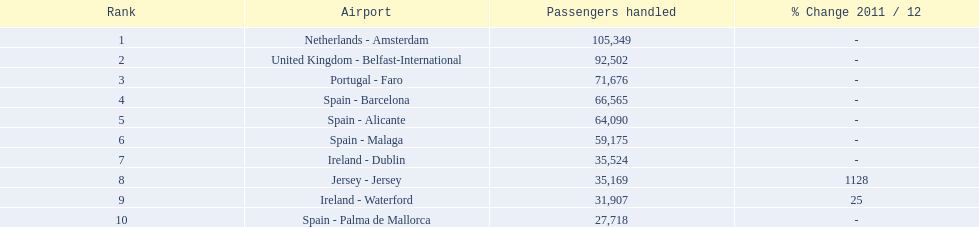What are all the passengers handled values for london southend airport? 105,349, 92,502, 71,676, 66,565, 64,090, 59,175, 35,524, 35,169, 31,907, 27,718. Which are 30,000 or less? 27,718. What airport is this for? Spain - Palma de Mallorca. 